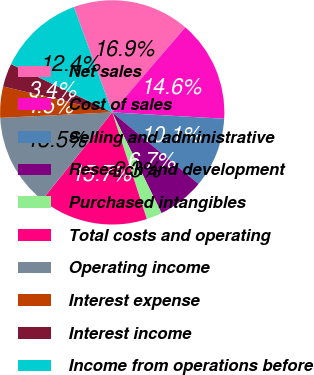<chart> <loc_0><loc_0><loc_500><loc_500><pie_chart><fcel>Net sales<fcel>Cost of sales<fcel>Selling and administrative<fcel>Research and development<fcel>Purchased intangibles<fcel>Total costs and operating<fcel>Operating income<fcel>Interest expense<fcel>Interest income<fcel>Income from operations before<nl><fcel>16.85%<fcel>14.61%<fcel>10.11%<fcel>6.74%<fcel>2.25%<fcel>15.73%<fcel>13.48%<fcel>4.49%<fcel>3.37%<fcel>12.36%<nl></chart> 